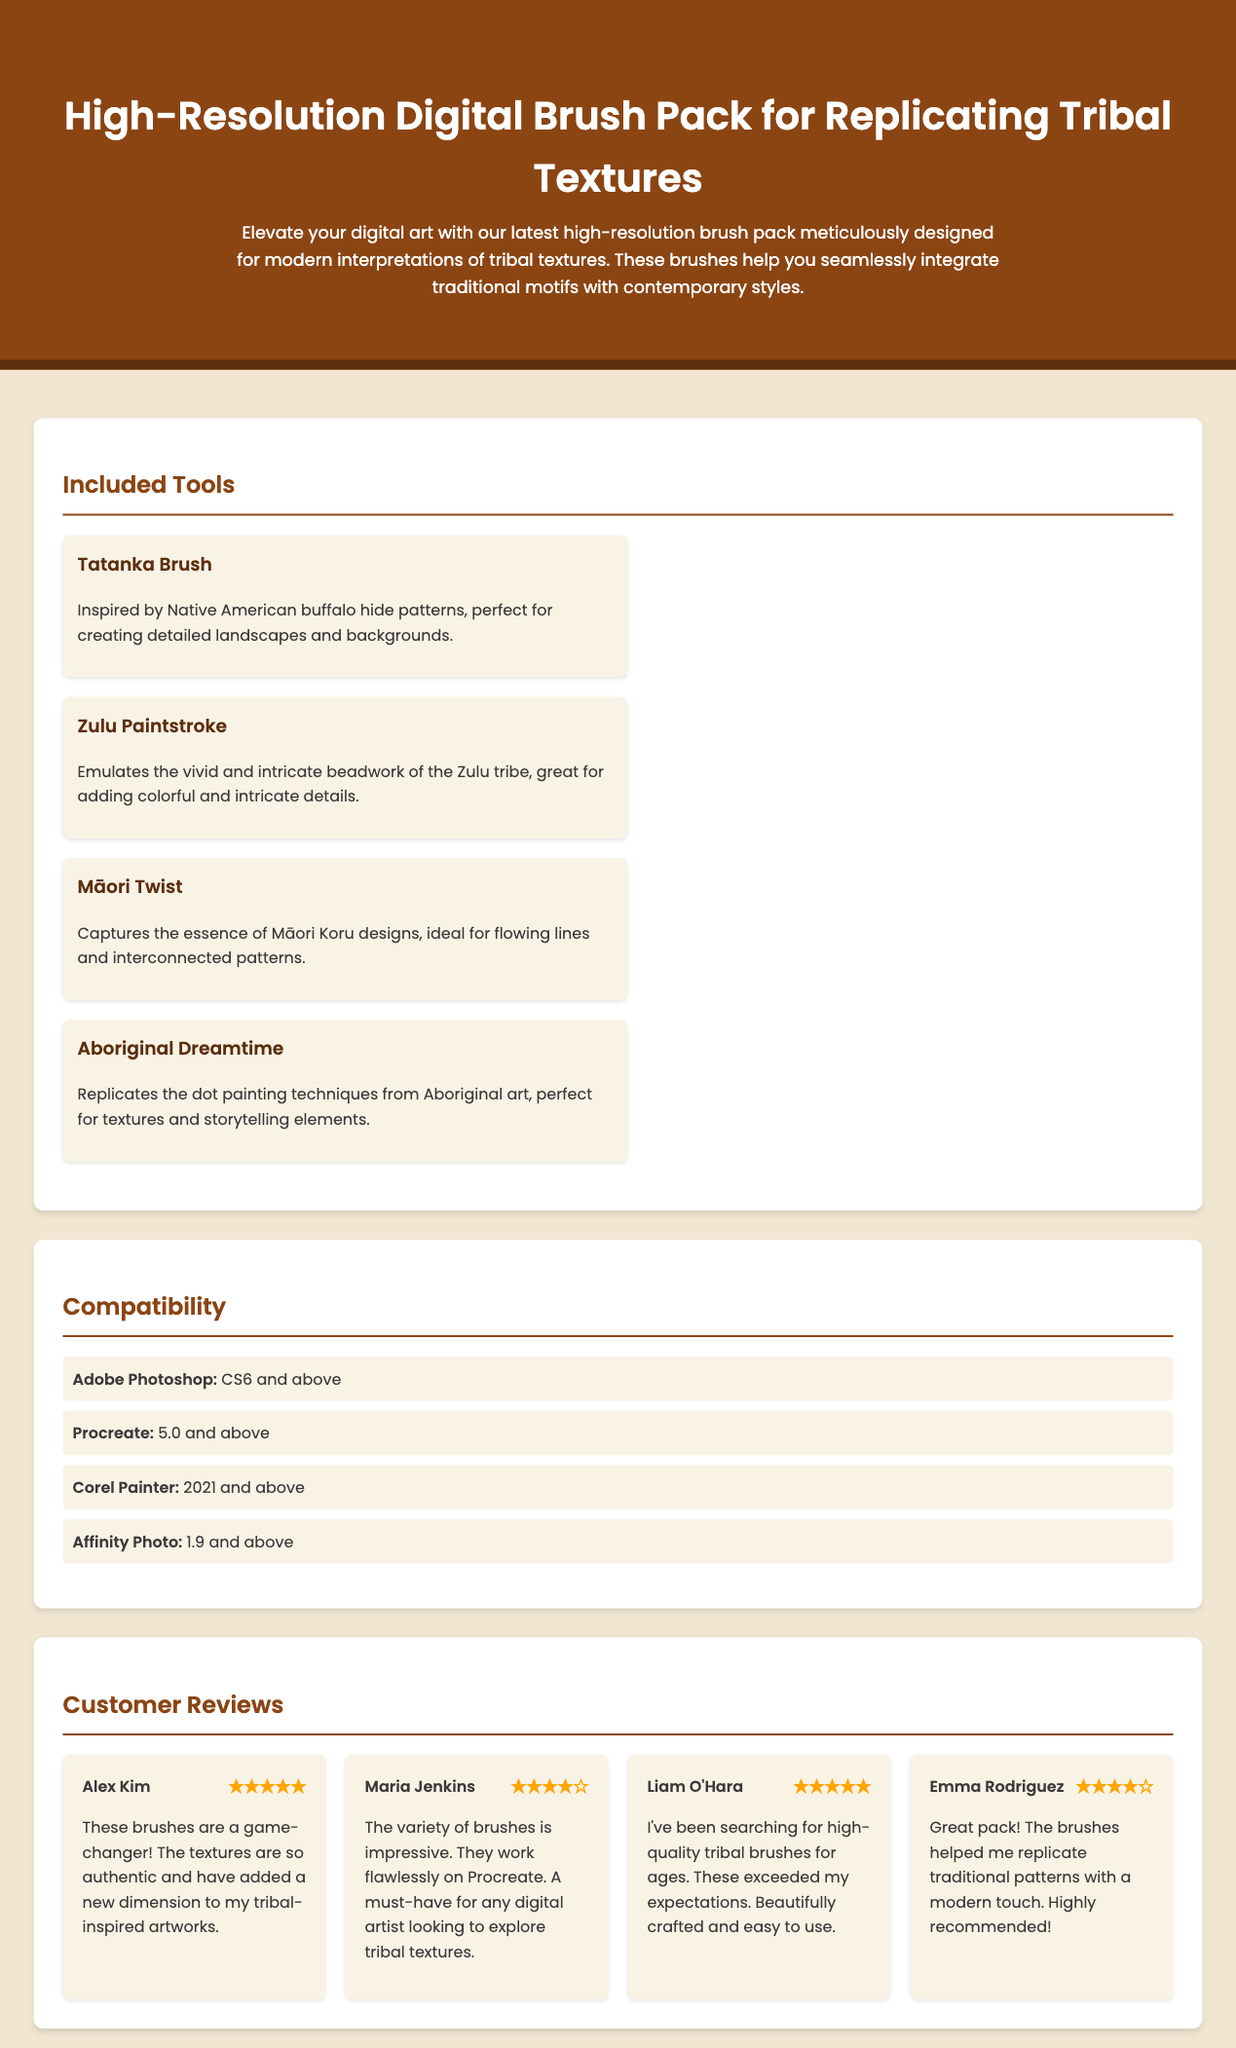What is the title of the product? The title of the product is mentioned in the header of the document.
Answer: High-Resolution Digital Brush Pack for Replicating Tribal Textures How many brushes are included in the pack? The document lists four specific brushes under Included Tools.
Answer: Four What is the rating of Alex Kim's review? The review section shows the rating given by Alex Kim.
Answer: ★★★★★ Which software is compatible with the brush pack? Compatibility section lists specific software that works with the brush pack.
Answer: Adobe Photoshop, Procreate, Corel Painter, Affinity Photo What style does the "Tatanka Brush" emulate? The description of the "Tatanka Brush" provides insight into its inspired design.
Answer: Native American buffalo hide patterns Who wrote the review that received four stars? The customer reviews section specifies the names of reviewers along with their ratings.
Answer: Maria Jenkins What is a unique feature of the "Aboriginal Dreamtime" brush? The description of "Aboriginal Dreamtime" highlights its specific technique used.
Answer: Replicates the dot painting techniques Which brush is ideal for flowing lines? The document specifies which brush captures the essence of flowing lines.
Answer: Māori Twist 